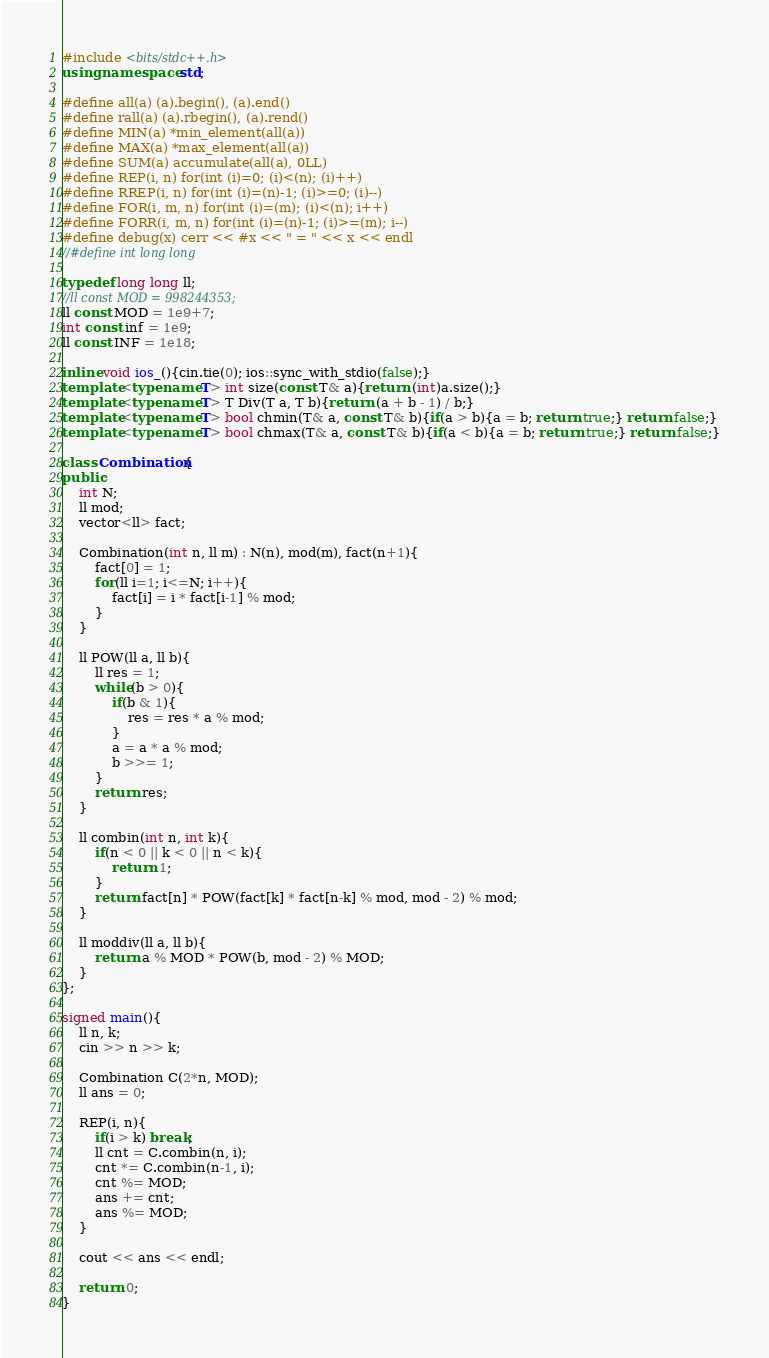Convert code to text. <code><loc_0><loc_0><loc_500><loc_500><_C++_>#include <bits/stdc++.h>
using namespace std;

#define all(a) (a).begin(), (a).end()
#define rall(a) (a).rbegin(), (a).rend()
#define MIN(a) *min_element(all(a))
#define MAX(a) *max_element(all(a))
#define SUM(a) accumulate(all(a), 0LL)
#define REP(i, n) for(int (i)=0; (i)<(n); (i)++)
#define RREP(i, n) for(int (i)=(n)-1; (i)>=0; (i)--)
#define FOR(i, m, n) for(int (i)=(m); (i)<(n); i++)
#define FORR(i, m, n) for(int (i)=(n)-1; (i)>=(m); i--)
#define debug(x) cerr << #x << " = " << x << endl
//#define int long long

typedef long long ll;
//ll const MOD = 998244353;
ll const MOD = 1e9+7;
int const inf = 1e9;
ll const INF = 1e18;

inline void ios_(){cin.tie(0); ios::sync_with_stdio(false);}
template<typename T> int size(const T& a){return (int)a.size();}
template<typename T> T Div(T a, T b){return (a + b - 1) / b;}
template<typename T> bool chmin(T& a, const T& b){if(a > b){a = b; return true;} return false;}
template<typename T> bool chmax(T& a, const T& b){if(a < b){a = b; return true;} return false;}

class Combination{
public:
    int N;
    ll mod;
    vector<ll> fact;

    Combination(int n, ll m) : N(n), mod(m), fact(n+1){
        fact[0] = 1;
        for(ll i=1; i<=N; i++){
            fact[i] = i * fact[i-1] % mod;
        }
    }

    ll POW(ll a, ll b){
        ll res = 1;
        while(b > 0){
            if(b & 1){
                res = res * a % mod;
            }
            a = a * a % mod;
            b >>= 1;
        }
        return res;
    }

    ll combin(int n, int k){
        if(n < 0 || k < 0 || n < k){
            return 1;
        }
        return fact[n] * POW(fact[k] * fact[n-k] % mod, mod - 2) % mod;
    }

    ll moddiv(ll a, ll b){
        return a % MOD * POW(b, mod - 2) % MOD;
    }
};

signed main(){
    ll n, k;
    cin >> n >> k;

    Combination C(2*n, MOD);
    ll ans = 0;

    REP(i, n){
        if(i > k) break;
        ll cnt = C.combin(n, i);
        cnt *= C.combin(n-1, i);
        cnt %= MOD;
        ans += cnt;
        ans %= MOD;
    }

    cout << ans << endl;

    return 0;
}
</code> 